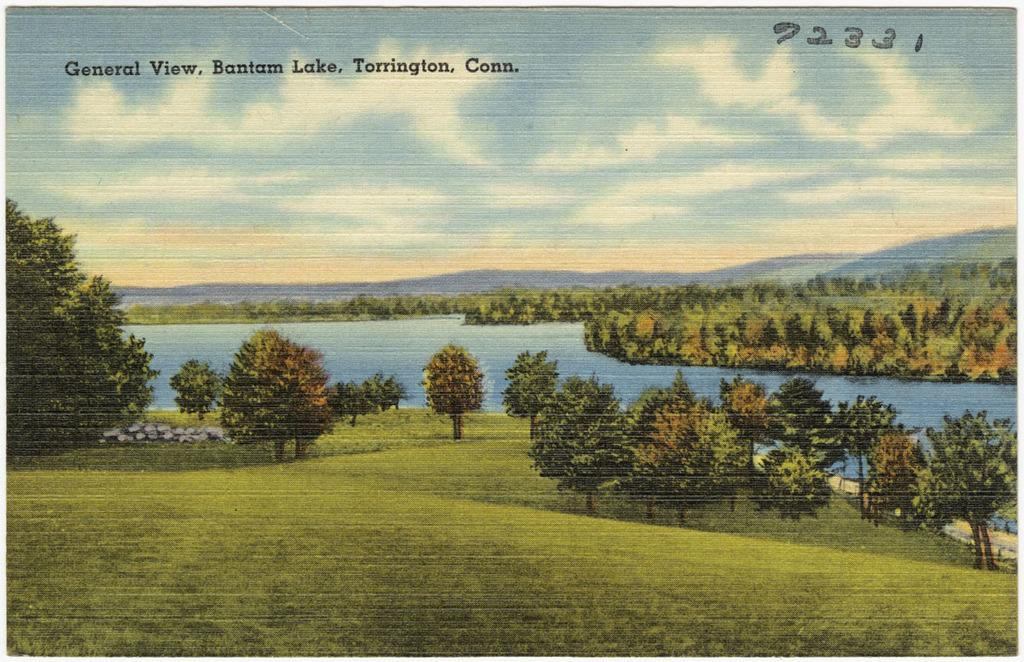What is depicted on the poster in the image? The poster contains trees, green grass, water, and clouds in the sky. Can you describe the landscape on the poster? The poster features a landscape with trees, green grass, and water in the middle. What is visible in the sky on the poster? There are clouds in the sky at the top of the poster. What type of plastic is used to create the crayon in the image? There is no crayon or plastic present in the image; it features a poster with trees, green grass, water, and clouds in the sky. How does the sleet affect the landscape on the poster? There is no sleet present in the image; the landscape features trees, green grass, water, and clouds in the sky. 